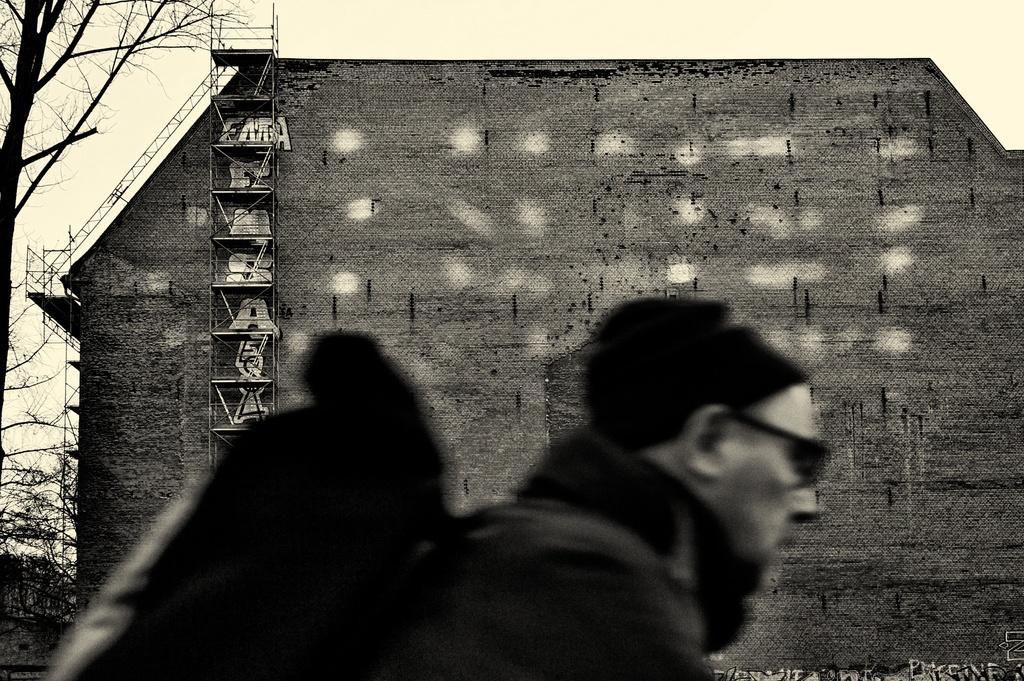Can you describe this image briefly? In the picture we can see a man wearing a bag and behind him we can see a building with some ladder to it and beside it, we can see a tree and in the background we can see a sky. 